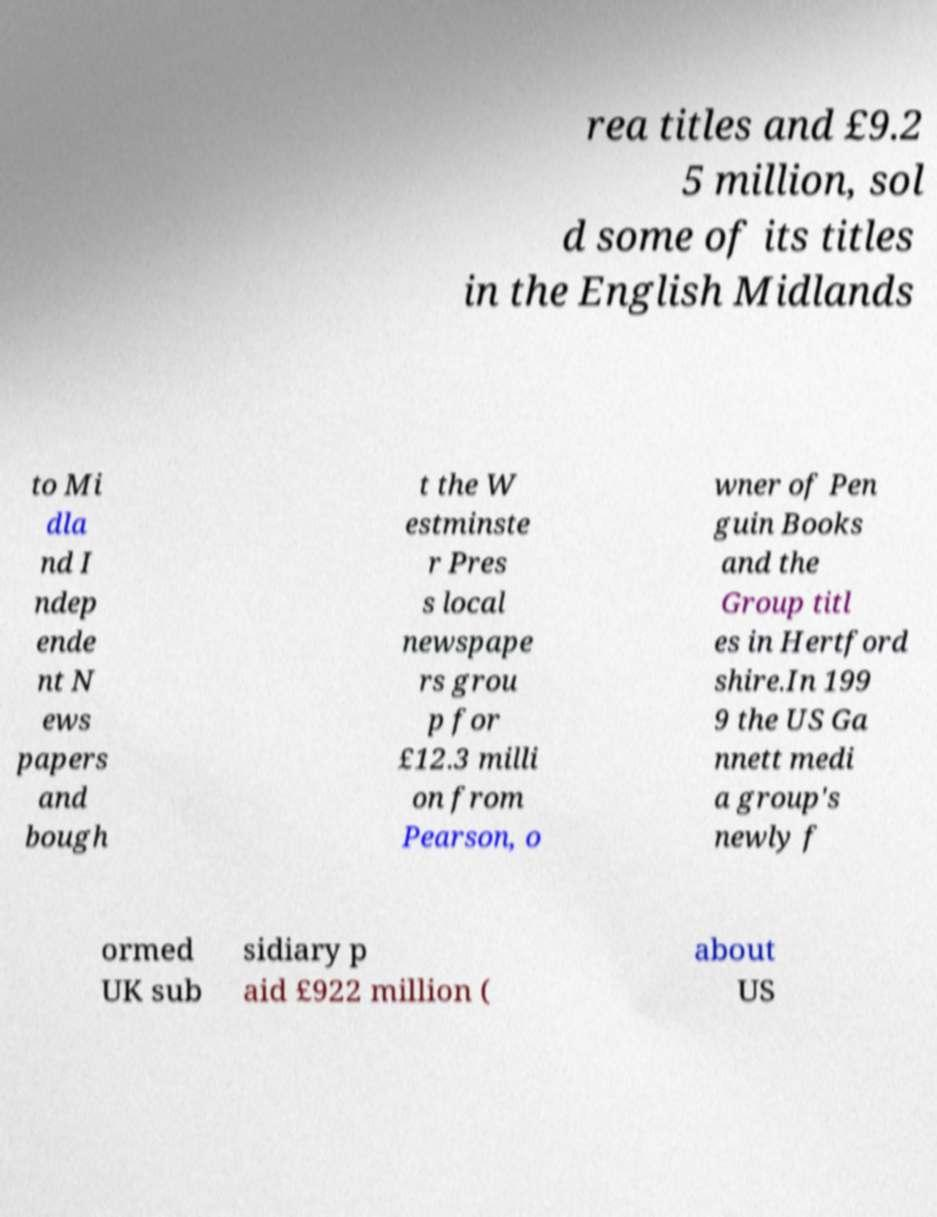Please read and relay the text visible in this image. What does it say? rea titles and £9.2 5 million, sol d some of its titles in the English Midlands to Mi dla nd I ndep ende nt N ews papers and bough t the W estminste r Pres s local newspape rs grou p for £12.3 milli on from Pearson, o wner of Pen guin Books and the Group titl es in Hertford shire.In 199 9 the US Ga nnett medi a group's newly f ormed UK sub sidiary p aid £922 million ( about US 